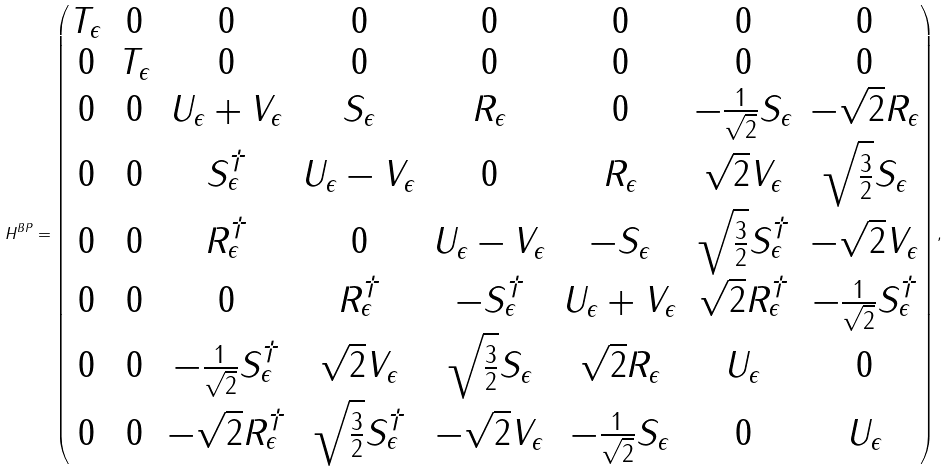<formula> <loc_0><loc_0><loc_500><loc_500>H ^ { B P } = \begin{pmatrix} T _ { \epsilon } & 0 & 0 & 0 & 0 & 0 & 0 & 0 \\ 0 & T _ { \epsilon } & 0 & 0 & 0 & 0 & 0 & 0 \\ 0 & 0 & U _ { \epsilon } + V _ { \epsilon } & S _ { \epsilon } & R _ { \epsilon } & 0 & - \frac { 1 } { \sqrt { 2 } } S _ { \epsilon } & - \sqrt { 2 } R _ { \epsilon } \\ 0 & 0 & S _ { \epsilon } ^ { \dag } & U _ { \epsilon } - V _ { \epsilon } & 0 & R _ { \epsilon } & \sqrt { 2 } V _ { \epsilon } & \sqrt { \frac { 3 } { 2 } } S _ { \epsilon } \\ 0 & 0 & R _ { \epsilon } ^ { \dag } & 0 & U _ { \epsilon } - V _ { \epsilon } & - S _ { \epsilon } & \sqrt { \frac { 3 } { 2 } } S _ { \epsilon } ^ { \dag } & - \sqrt { 2 } V _ { \epsilon } \\ 0 & 0 & 0 & R _ { \epsilon } ^ { \dag } & - S _ { \epsilon } ^ { \dag } & U _ { \epsilon } + V _ { \epsilon } & \sqrt { 2 } R _ { \epsilon } ^ { \dag } & - \frac { 1 } { \sqrt { 2 } } S _ { \epsilon } ^ { \dag } \\ 0 & 0 & - \frac { 1 } { \sqrt { 2 } } S _ { \epsilon } ^ { \dag } & \sqrt { 2 } V _ { \epsilon } & \sqrt { \frac { 3 } { 2 } } S _ { \epsilon } & \sqrt { 2 } R _ { \epsilon } & U _ { \epsilon } & 0 \\ 0 & 0 & - \sqrt { 2 } R _ { \epsilon } ^ { \dag } & \sqrt { \frac { 3 } { 2 } } S _ { \epsilon } ^ { \dag } & - \sqrt { 2 } V _ { \epsilon } & - \frac { 1 } { \sqrt { 2 } } S _ { \epsilon } & 0 & U _ { \epsilon } \end{pmatrix} ,</formula> 